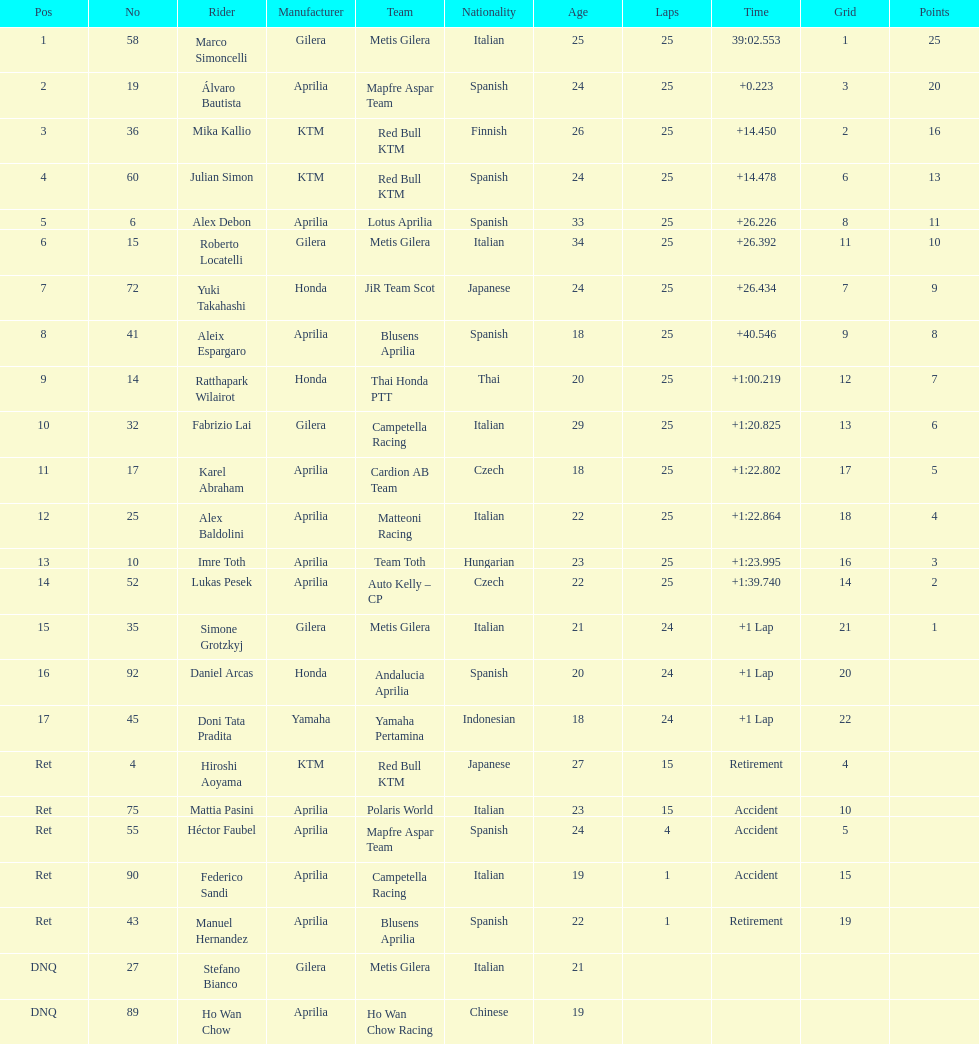Did marco simoncelli or alvaro bautista held rank 1? Marco Simoncelli. 